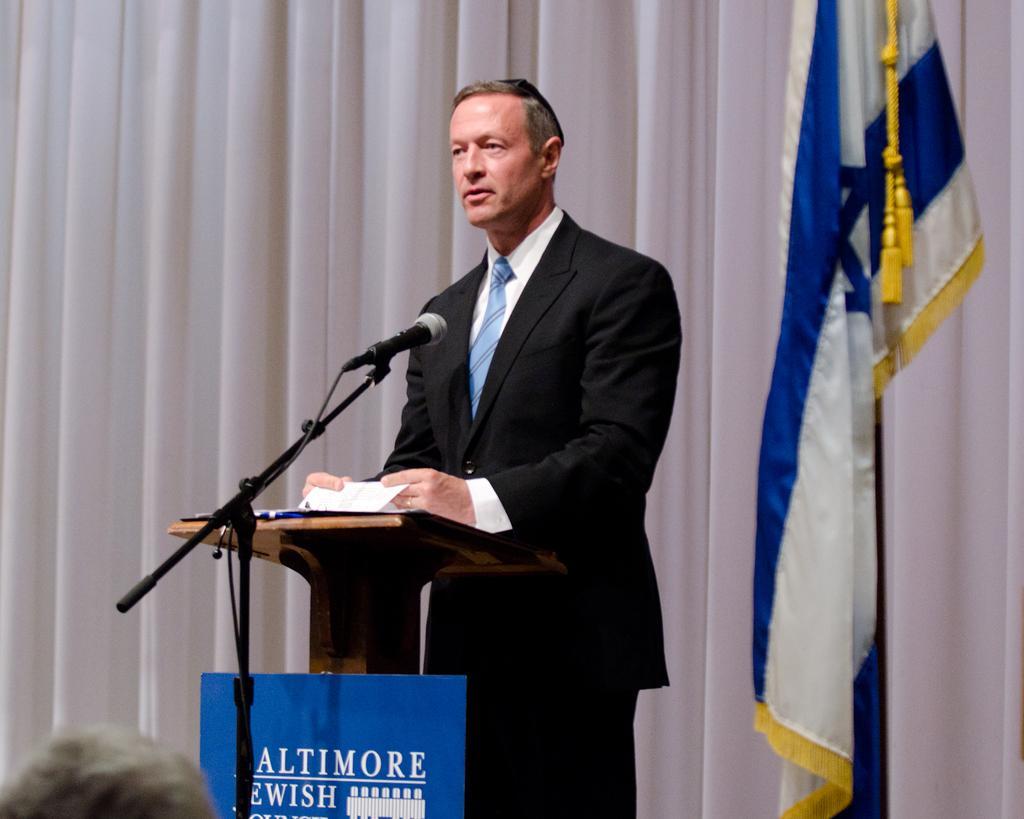Could you give a brief overview of what you see in this image? There is a man standing and holding a paper,in front of this man we can see board attached on the podium and microphone with stand,behind this man we can see curtains,beside this man we can see flag. In the bottom left side of the image we can see person head. 